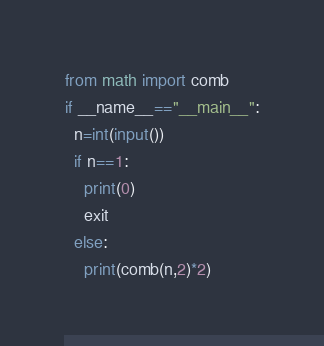<code> <loc_0><loc_0><loc_500><loc_500><_Python_>from math import comb
if __name__=="__main__":
  n=int(input())
  if n==1:
    print(0)
    exit
  else:
    print(comb(n,2)*2)
</code> 